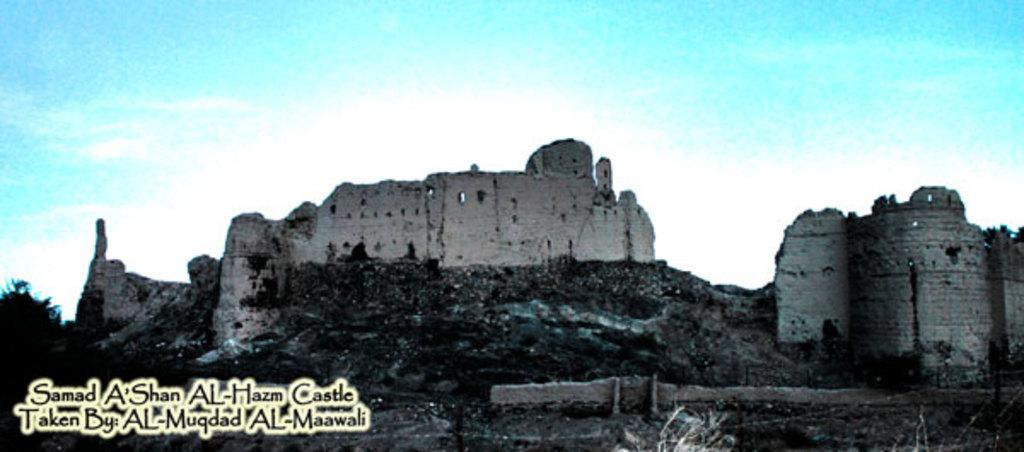What type of structure is in the image? There is a fort in the image. What other natural element is present in the image? There is a tree in the image. Where can text be found in the image? The text is in the bottom left side of the image. What can be seen in the background of the image? The sky is visible in the background of the image. How many nails are visible in the image? There are no nails present in the image. What type of face can be seen on the fort in the image? There is no face depicted on the fort in the image. 